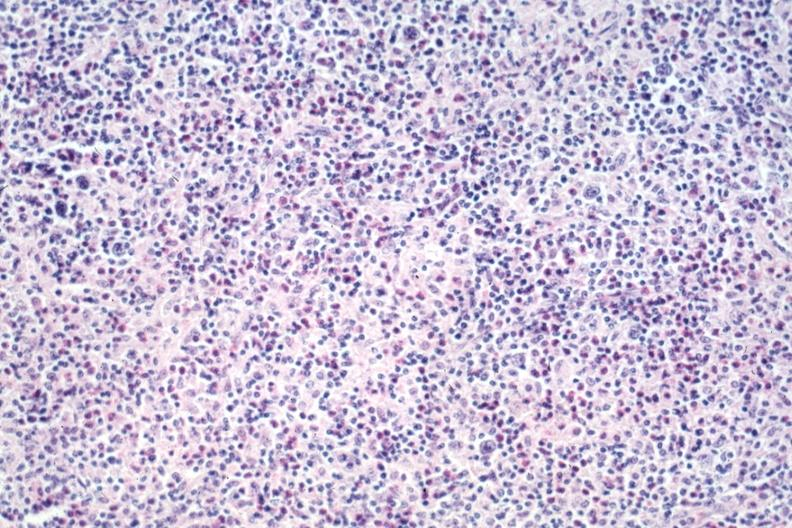s lymph node present?
Answer the question using a single word or phrase. Yes 